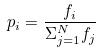Convert formula to latex. <formula><loc_0><loc_0><loc_500><loc_500>p _ { i } = \frac { f _ { i } } { \Sigma _ { j = 1 } ^ { N } f _ { j } }</formula> 